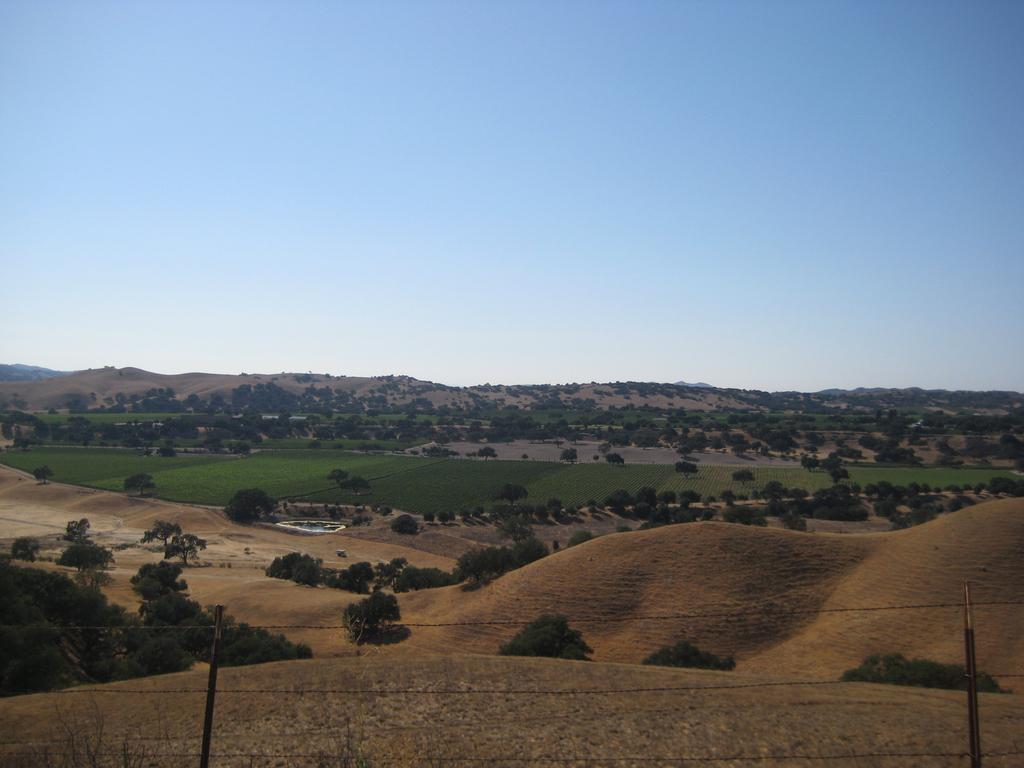What is the primary feature of the image? There is a lot of land in the image. Are there any specific objects or structures on the land? There are a few trees on the land. What can be seen behind the land? There is a lot of greenery behind the land. Can you see a basin in the image? There is no basin present in the image. Are there any pigs visible in the image? There are no pigs present in the image. 